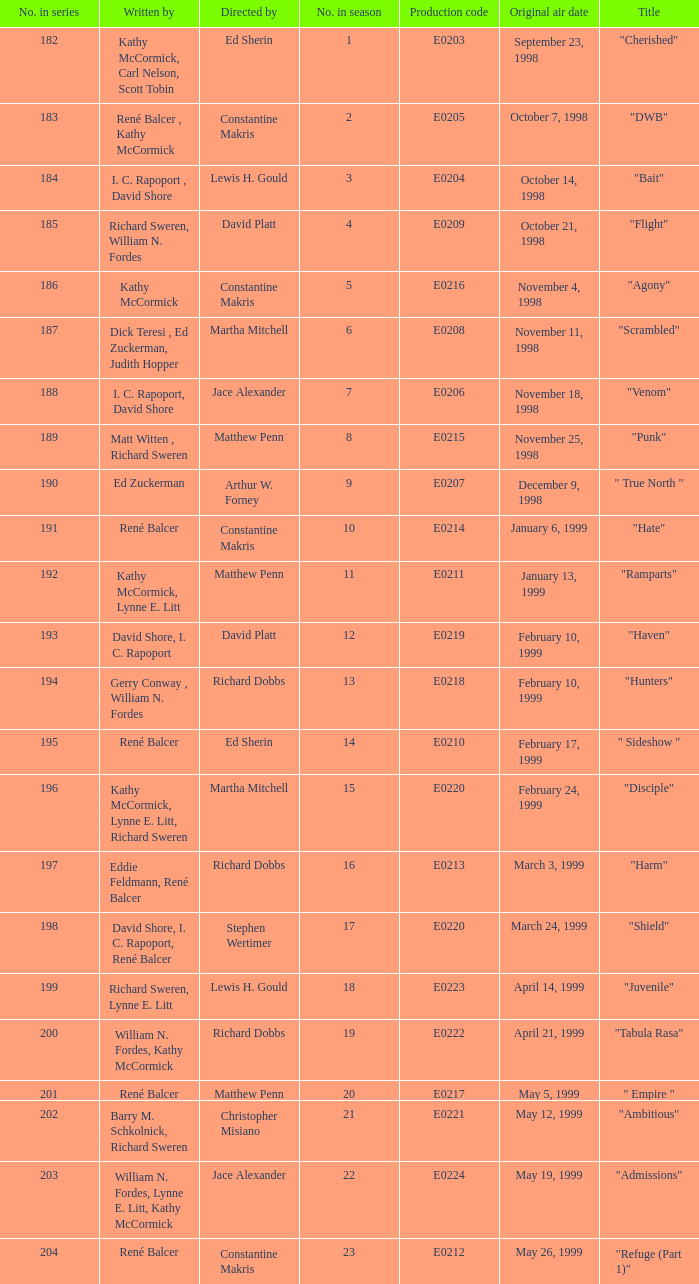Which season number includes an episode authored by matt witten and richard sweren? 8.0. 